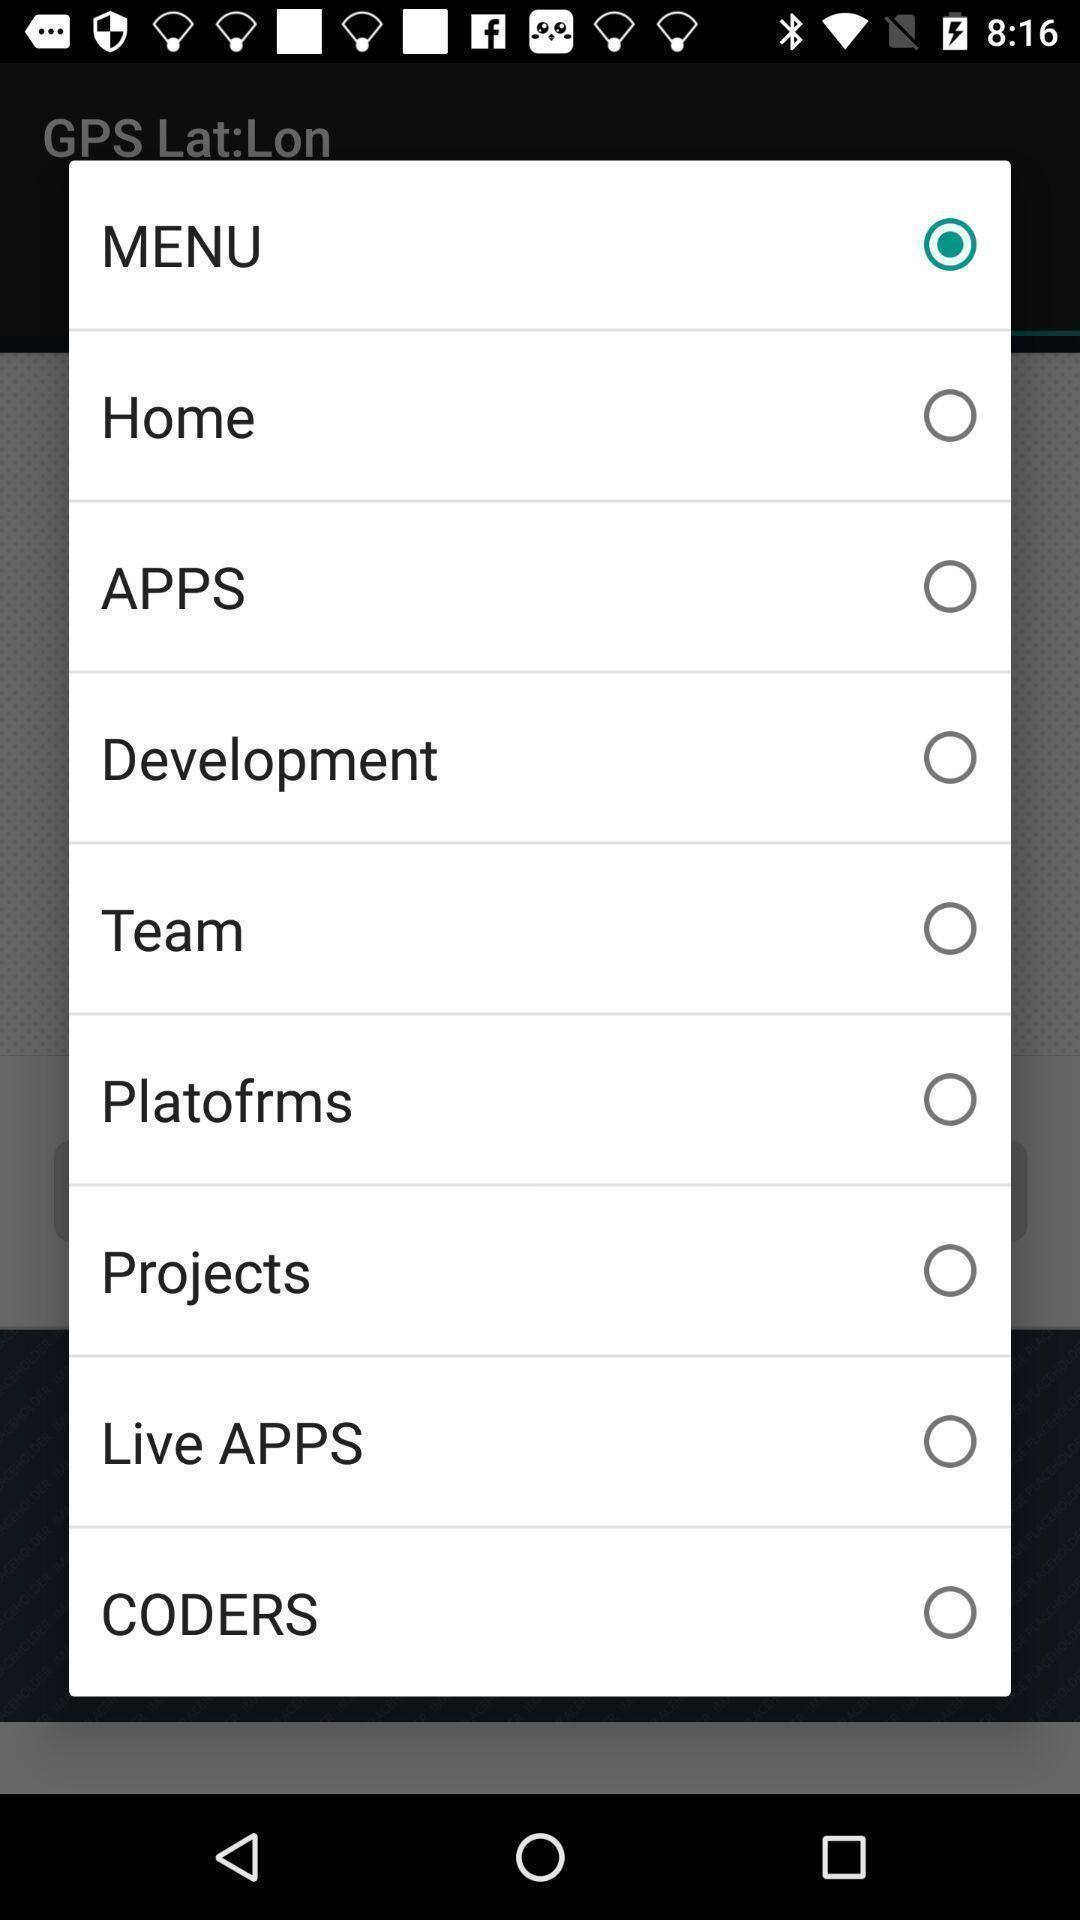Provide a detailed account of this screenshot. Popup showing different options to select. 